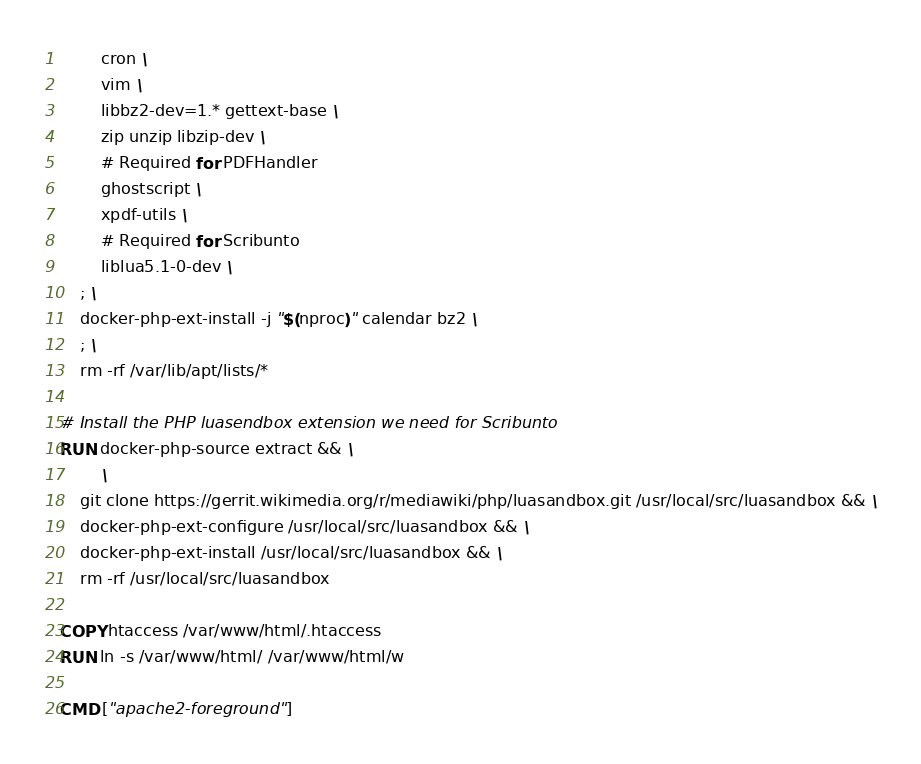Convert code to text. <code><loc_0><loc_0><loc_500><loc_500><_Dockerfile_>		cron \
		vim \
		libbz2-dev=1.* gettext-base \
		zip unzip libzip-dev \
		# Required for PDFHandler
		ghostscript \
		xpdf-utils \
		# Required for Scribunto
		liblua5.1-0-dev \
	; \
	docker-php-ext-install -j "$(nproc)" calendar bz2 \
	; \
	rm -rf /var/lib/apt/lists/*

# Install the PHP luasendbox extension we need for Scribunto
RUN docker-php-source extract && \
        \
	git clone https://gerrit.wikimedia.org/r/mediawiki/php/luasandbox.git /usr/local/src/luasandbox && \
	docker-php-ext-configure /usr/local/src/luasandbox && \
	docker-php-ext-install /usr/local/src/luasandbox && \
	rm -rf /usr/local/src/luasandbox

COPY htaccess /var/www/html/.htaccess
RUN ln -s /var/www/html/ /var/www/html/w

CMD ["apache2-foreground"]
</code> 